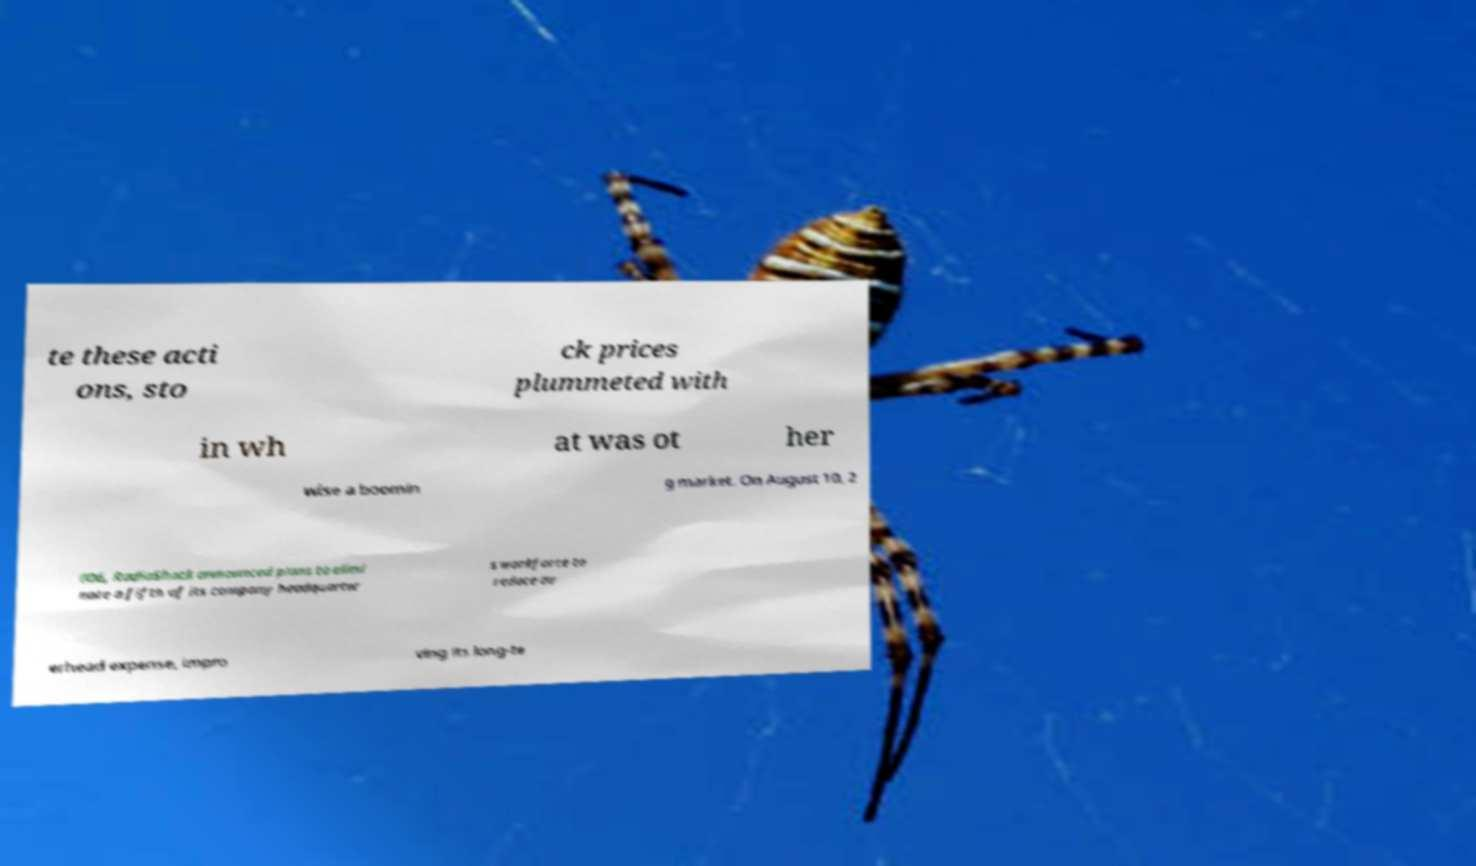Could you extract and type out the text from this image? te these acti ons, sto ck prices plummeted with in wh at was ot her wise a boomin g market. On August 10, 2 006, RadioShack announced plans to elimi nate a fifth of its company headquarter s workforce to reduce ov erhead expense, impro ving its long-te 